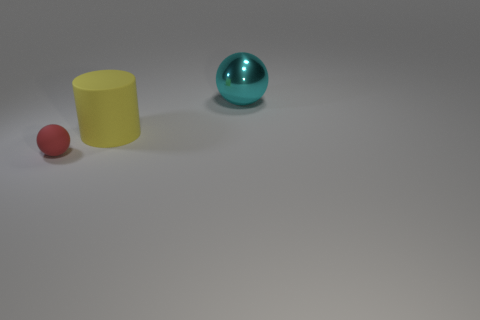Is there any other thing that is the same size as the red rubber ball?
Provide a short and direct response. No. Is the size of the sphere behind the red sphere the same as the red object?
Your answer should be very brief. No. There is a tiny object that is the same shape as the big cyan object; what is its material?
Make the answer very short. Rubber. Is the number of tiny red rubber balls greater than the number of brown rubber cubes?
Your answer should be very brief. Yes. Does the large cylinder have the same color as the big object that is on the right side of the yellow rubber object?
Offer a terse response. No. What is the color of the thing that is behind the small ball and in front of the large metal ball?
Ensure brevity in your answer.  Yellow. What number of other objects are the same material as the cylinder?
Your response must be concise. 1. Is the number of yellow rubber cylinders less than the number of balls?
Give a very brief answer. Yes. Does the red object have the same material as the large thing to the left of the large sphere?
Your answer should be very brief. Yes. What is the shape of the large object to the right of the big cylinder?
Your answer should be compact. Sphere. 